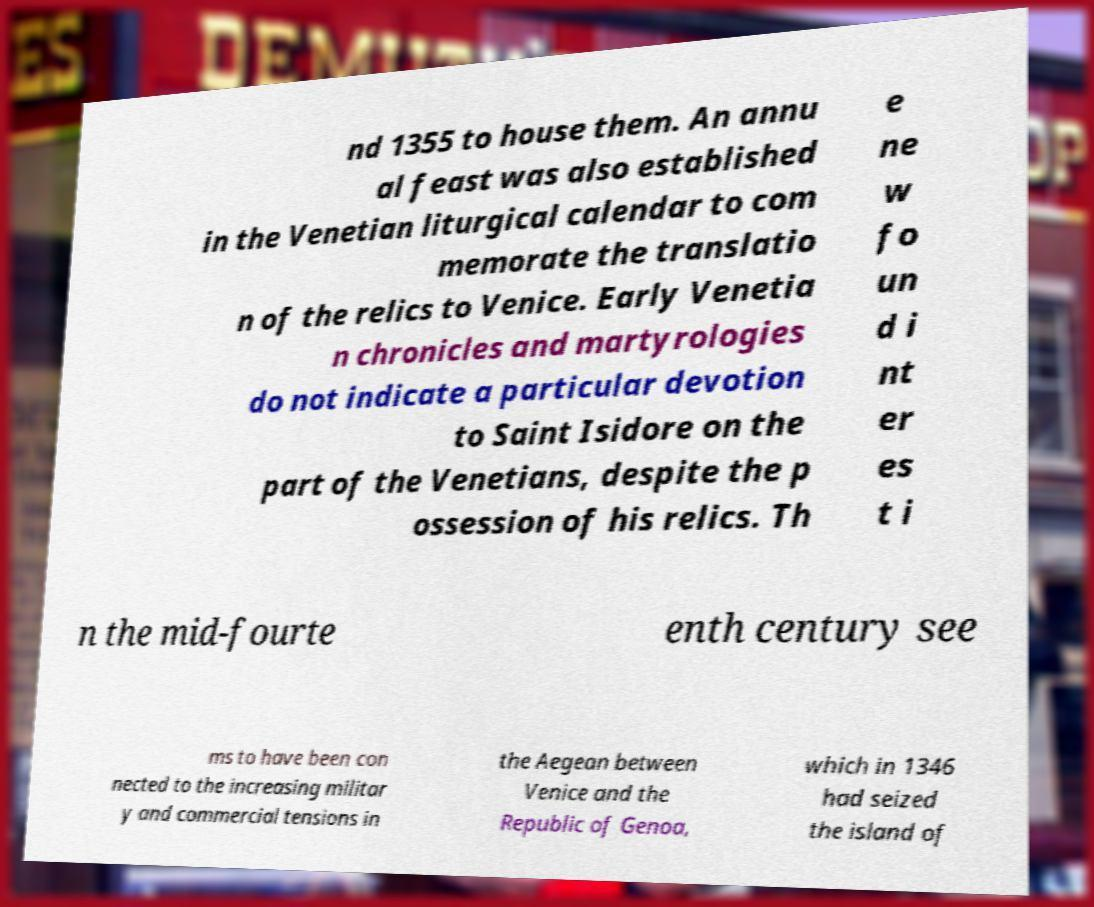Could you assist in decoding the text presented in this image and type it out clearly? nd 1355 to house them. An annu al feast was also established in the Venetian liturgical calendar to com memorate the translatio n of the relics to Venice. Early Venetia n chronicles and martyrologies do not indicate a particular devotion to Saint Isidore on the part of the Venetians, despite the p ossession of his relics. Th e ne w fo un d i nt er es t i n the mid-fourte enth century see ms to have been con nected to the increasing militar y and commercial tensions in the Aegean between Venice and the Republic of Genoa, which in 1346 had seized the island of 